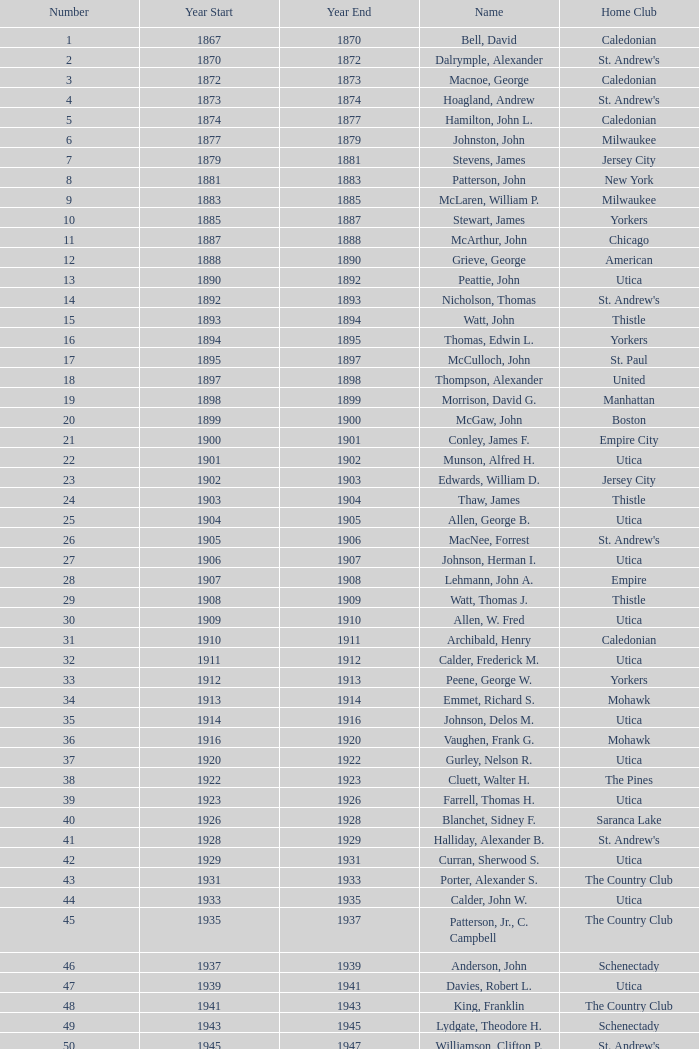Which Number has a Year Start smaller than 1874, and a Year End larger than 1873? 4.0. 